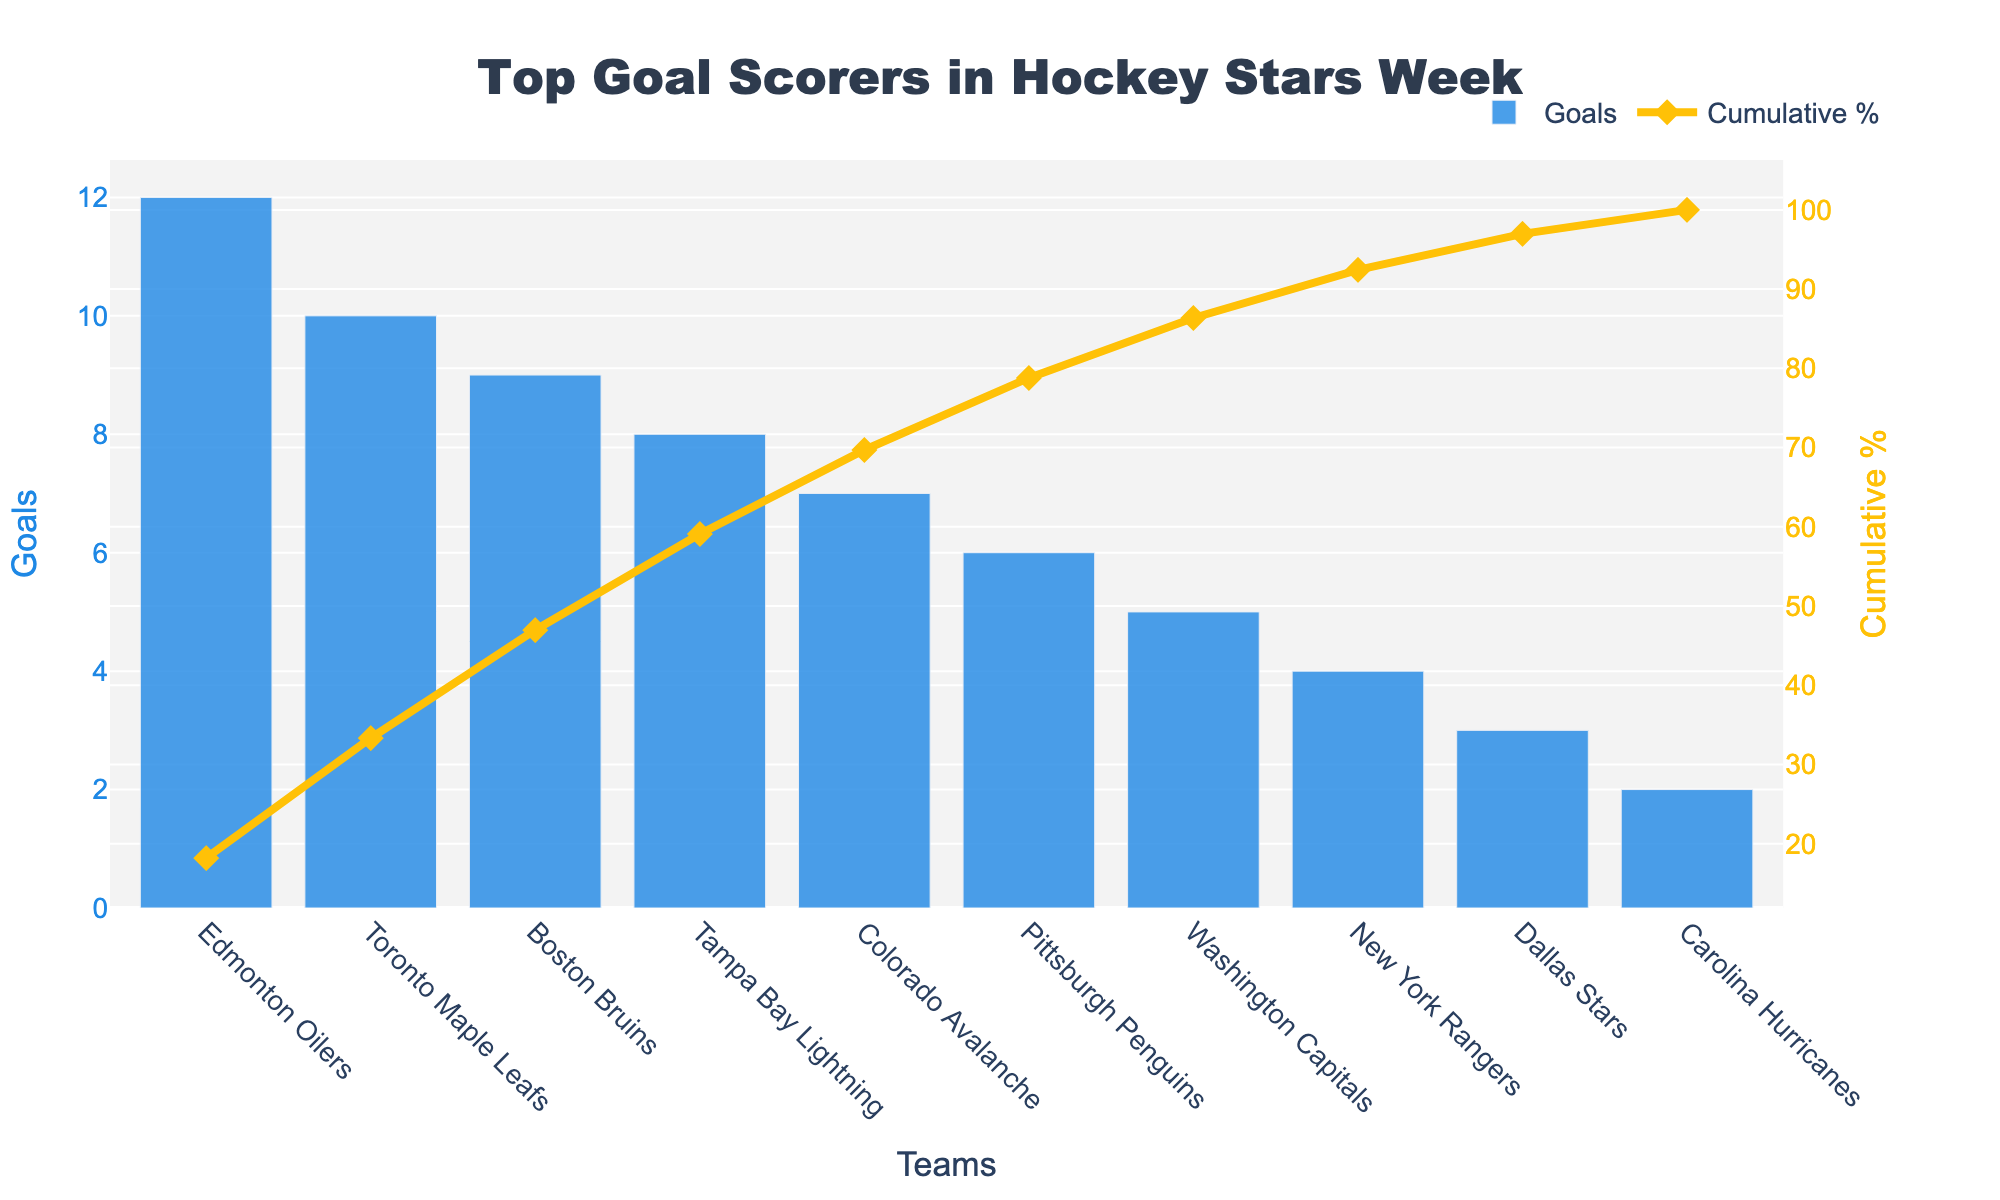what is the title of the figure? The title is usually found at the top of the plot and is a key element that indicates the purpose or subject of the figure. In this case, the title reads "Top Goal Scorers in Hockey Stars Week".
Answer: Top Goal Scorers in Hockey Stars Week How many teams are listed in the figure? The figure shows bars representing the number of goals scored by each team. Counting the number of bars will give the number of teams.
Answer: 10 Which team scored the highest number of goals? The team with the highest bar in the figure indicates the highest number of goals. Here, the Edmonton Oilers have the highest bar.
Answer: Edmonton Oilers What is the cumulative percentage of goals when including the Edmonton Oilers and Toronto Maple Leafs? To find this, you cumulatively add the goals of the top two teams (Edmonton Oilers: 12, Toronto Maple Leafs: 10) and divide by the total goals scored by all teams (52), then multiply by 100 to get the percentage. (12 + 10) / 52 * 100 = 42.31%.
Answer: 42.31% Which teams account for approximately 70% of the total goals scored? To answer this, look at the cumulative percentage line. Finding where it approaches 70% on the secondary y-axis shows that including the top four teams (Edmonton Oilers, Toronto Maple Leafs, Boston Bruins, and Tampa Bay Lightning) reaches about 73.08%.
Answer: Edmonton Oilers, Toronto Maple Leafs, Boston Bruins, Tampa Bay Lightning How many goals did the bottom three teams score in total? Adding the goals of the bottom three teams (Dallas Stars: 3, Carolina Hurricanes: 2, New York Rangers: 4) gives the total. 3 + 2 + 4 = 9.
Answer: 9 What is the difference in goals between the Boston Bruins and Carolina Hurricanes? This requires subtracting the goals scored by the Carolina Hurricanes from those scored by the Boston Bruins. 9 - 2 = 7.
Answer: 7 Which color represents the cumulative percentage line in the figure? The color of the cumulative percentage line in the figure is gold, as indicated by the line's description in the explanation ('#FFC107').
Answer: Gold What percentage of the total goals was scored by the Washington Capitals and the New York Rangers combined? Add the goals of the two teams (Washington Capitals: 5, New York Rangers: 4) and divide by the total goals (52), then multiply by 100. (5 + 4) / 52 * 100 = 17.31%.
Answer: 17.31% Is the cumulative percentage plotted on the primary or secondary y-axis? The figure's legend and y-axis titles help identify this. The cumulative percentage is plotted on the secondary y-axis, aligned with the right side of the chart.
Answer: Secondary y-axis 